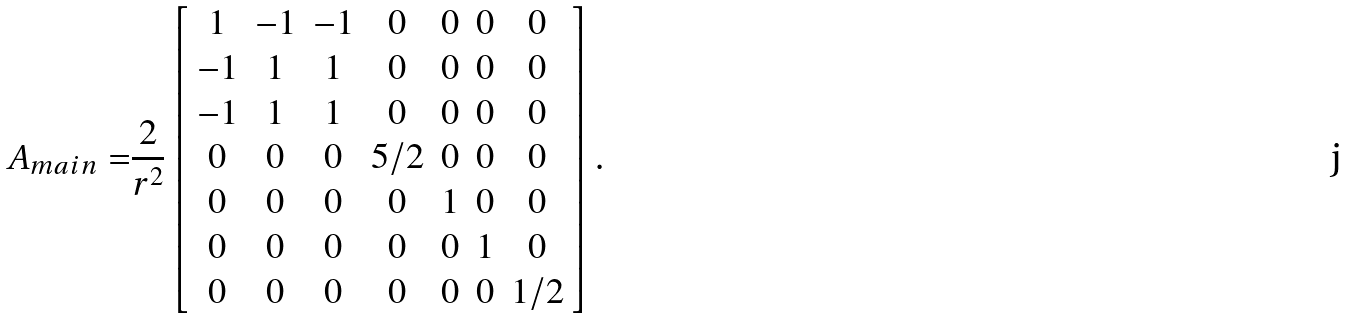Convert formula to latex. <formula><loc_0><loc_0><loc_500><loc_500>A _ { m a i n } = & \frac { 2 } { r ^ { 2 } } \left [ \begin{array} { c c c c c c c } 1 & - 1 & - 1 & 0 & 0 & 0 & 0 \\ - 1 & 1 & 1 & 0 & 0 & 0 & 0 \\ - 1 & 1 & 1 & 0 & 0 & 0 & 0 \\ 0 & 0 & 0 & 5 / 2 & 0 & 0 & 0 \\ 0 & 0 & 0 & 0 & 1 & 0 & 0 \\ 0 & 0 & 0 & 0 & 0 & 1 & 0 \\ 0 & 0 & 0 & 0 & 0 & 0 & 1 / 2 \end{array} \right ] .</formula> 